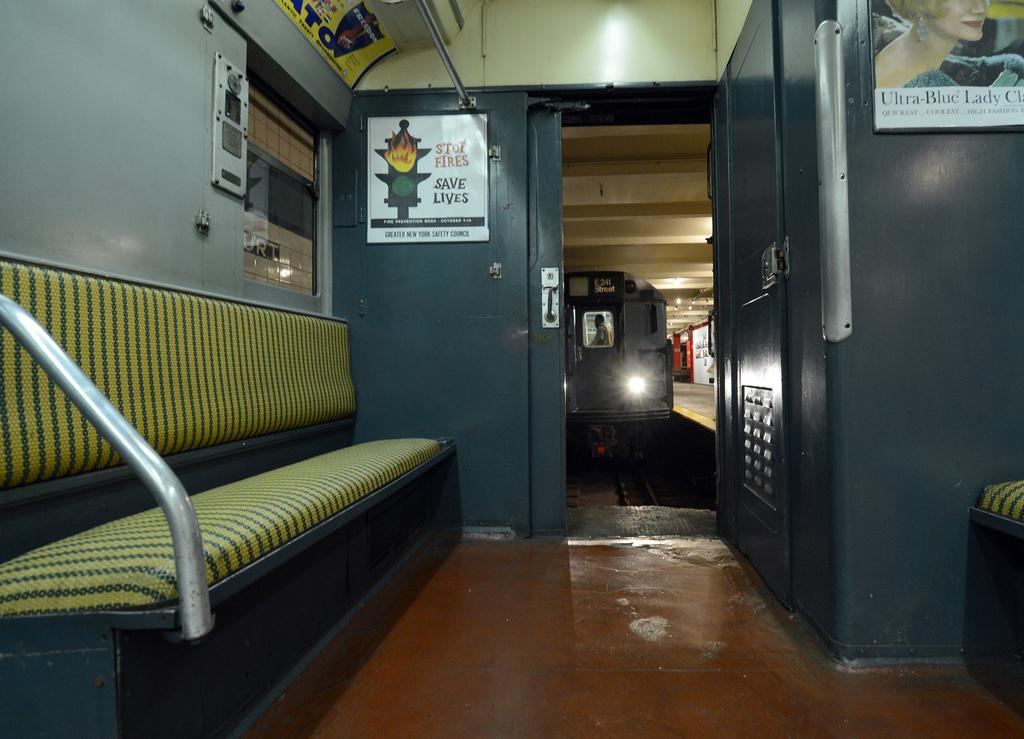<image>
Create a compact narrative representing the image presented. The wall of a subway car has a sign that says "Stop Fires. Save Lives." 